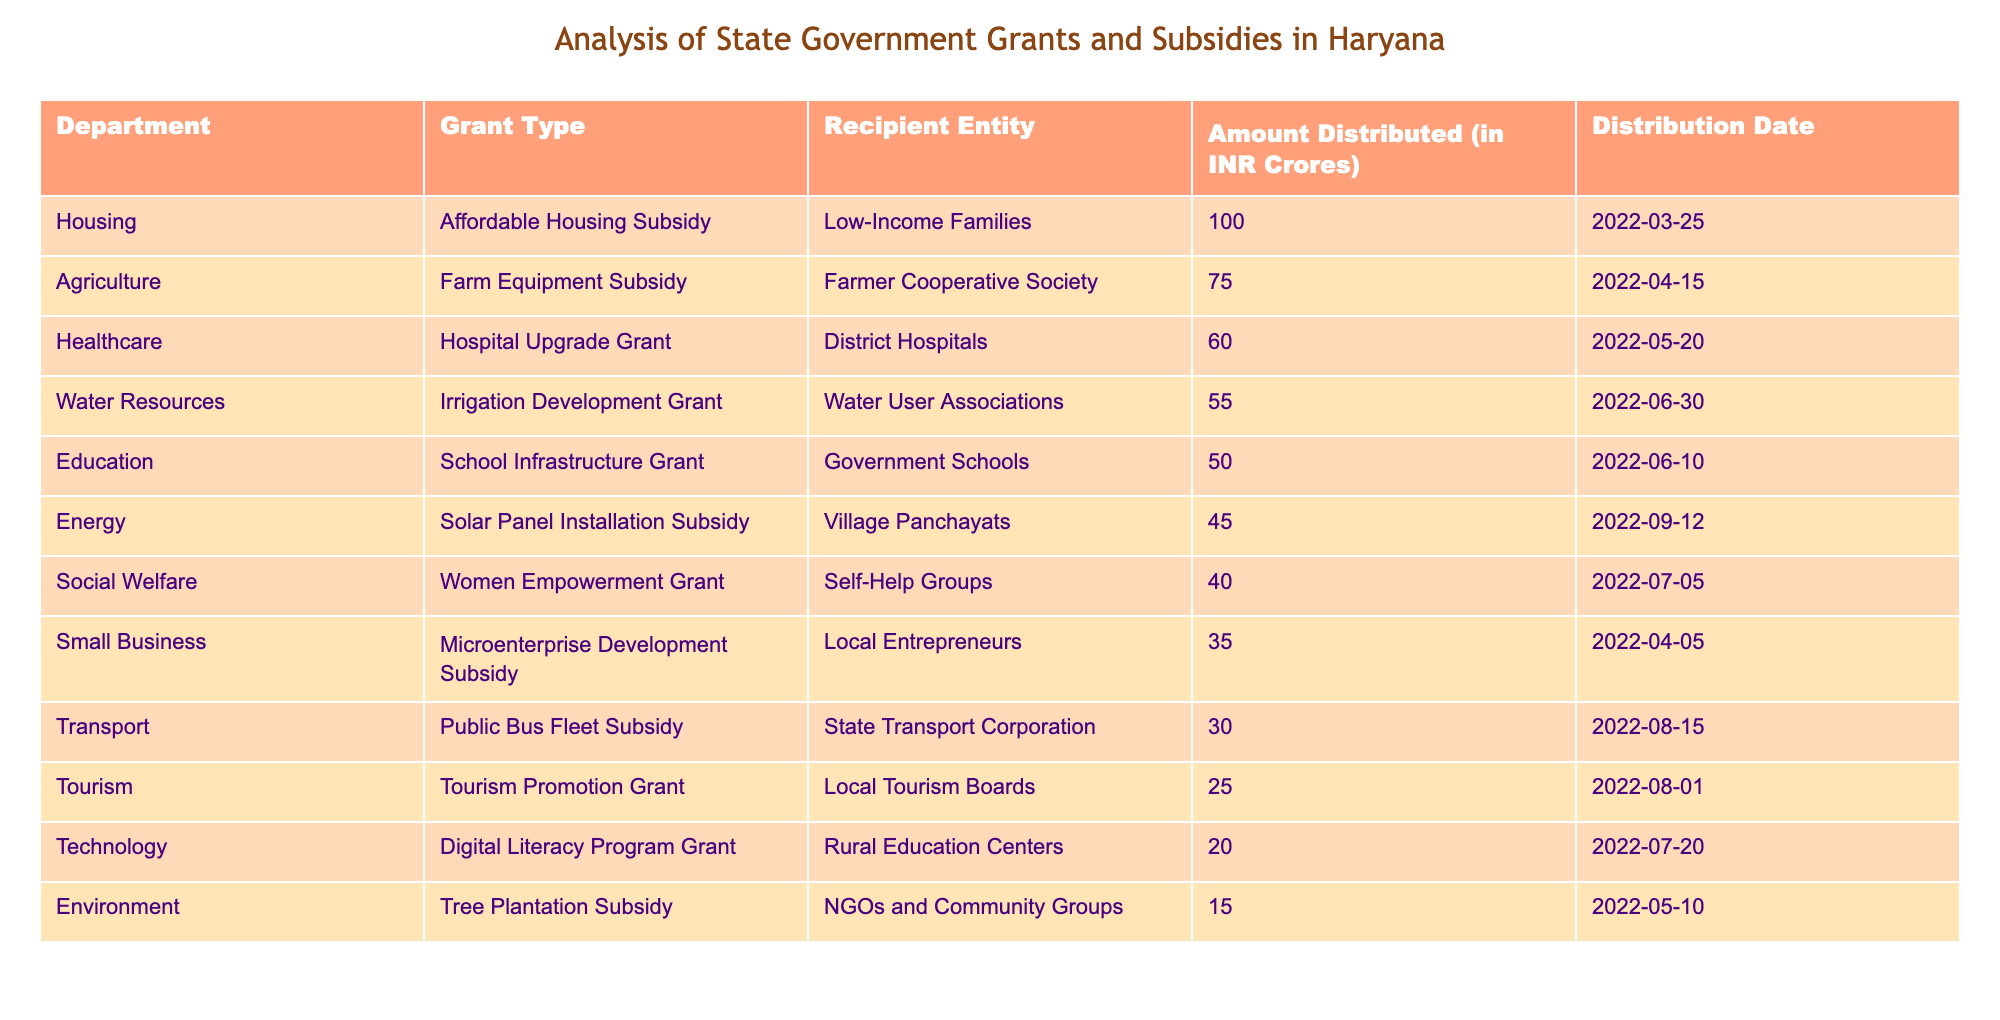What is the total amount distributed for the Housing department? The table lists only one entry for the Housing department with an amount of 100.0 crores. Therefore, the total amount distributed for Housing is simply that one entry.
Answer: 100.0 Which grant type received the least amount of funding? The table shows various grant types and their corresponding amounts. Scanning the amounts, the Tree Plantation Subsidy has the smallest amount of 15.0 crores, identifying it as the least funded grant type.
Answer: Tree Plantation Subsidy How much more was distributed to Affordable Housing than to Public Bus Fleet Subsidy? The amount for Affordable Housing is 100.0 crores, and for Public Bus Fleet Subsidy, it is 30.0 crores. We subtract the latter from the former: 100.0 - 30.0 = 70.0. Therefore, 70.0 crores more was allocated to Affordable Housing.
Answer: 70.0 Is the total amount distributed to the Education department greater than that of the Social Welfare department? The Education department received 50.0 crores and the Social Welfare department received 40.0 crores. Since 50.0 is greater than 40.0, the total amount for Education is indeed greater than for Social Welfare.
Answer: Yes What is the average amount distributed across all departments? First, we sum up all amounts: 75.0 + 50.0 + 60.0 + 40.0 + 30.0 + 45.0 + 100.0 + 55.0 + 20.0 + 35.0 + 25.0 + 15.0 =  525.0 crores. There are 12 departments, so the average is 525.0 / 12 = 43.75.
Answer: 43.75 Which recipient entity received the most funding and what was the amount? The table shows the amounts distributed to various entities, and the highest amount is 100.0 crores given to Low-Income Families under the Affordable Housing Subsidy.
Answer: Low-Income Families, 100.0 How much total funding was provided for grants related to Agriculture and Healthcare? The Agriculture department received 75.0 crores and Healthcare department received 60.0 crores. To find the total, we add these amounts: 75.0 + 60.0 = 135.0 crores.
Answer: 135.0 Was any funding provided for grants related to environment? The table includes the Tree Plantation Subsidy under the Environment category, which indicates it did receive funding.
Answer: Yes What percentage of the total funding was allocated to the Energy department? The total funding is 525.0 crores, and Energy received 45.0 crores. The percentage is calculated as (45.0 / 525.0) * 100 = 8.57 percent.
Answer: 8.57 percent 